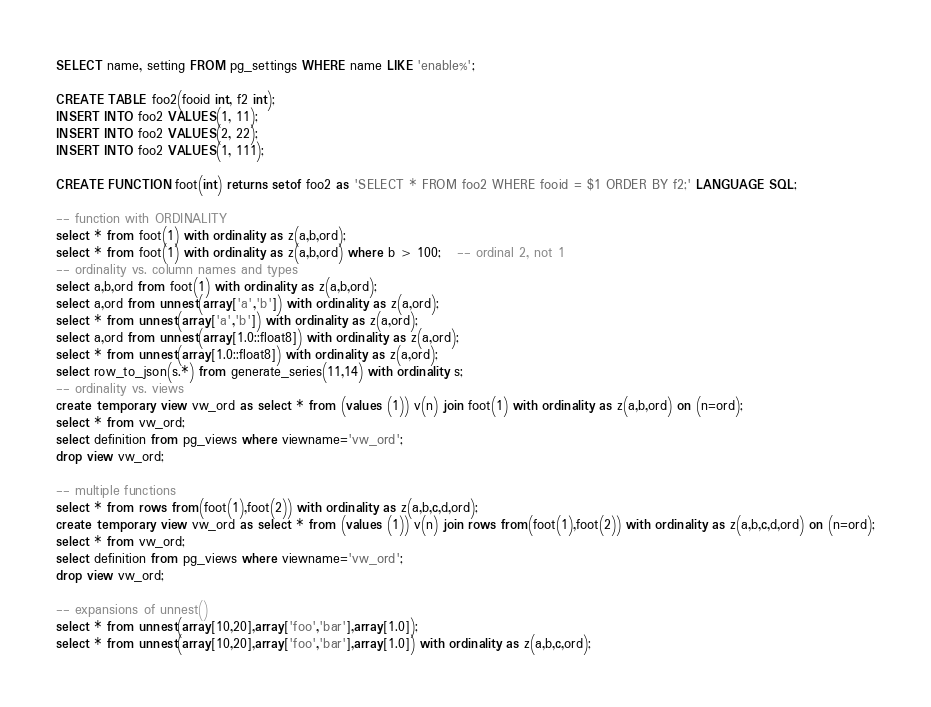Convert code to text. <code><loc_0><loc_0><loc_500><loc_500><_SQL_>SELECT name, setting FROM pg_settings WHERE name LIKE 'enable%';

CREATE TABLE foo2(fooid int, f2 int);
INSERT INTO foo2 VALUES(1, 11);
INSERT INTO foo2 VALUES(2, 22);
INSERT INTO foo2 VALUES(1, 111);

CREATE FUNCTION foot(int) returns setof foo2 as 'SELECT * FROM foo2 WHERE fooid = $1 ORDER BY f2;' LANGUAGE SQL;

-- function with ORDINALITY
select * from foot(1) with ordinality as z(a,b,ord);
select * from foot(1) with ordinality as z(a,b,ord) where b > 100;   -- ordinal 2, not 1
-- ordinality vs. column names and types
select a,b,ord from foot(1) with ordinality as z(a,b,ord);
select a,ord from unnest(array['a','b']) with ordinality as z(a,ord);
select * from unnest(array['a','b']) with ordinality as z(a,ord);
select a,ord from unnest(array[1.0::float8]) with ordinality as z(a,ord);
select * from unnest(array[1.0::float8]) with ordinality as z(a,ord);
select row_to_json(s.*) from generate_series(11,14) with ordinality s;
-- ordinality vs. views
create temporary view vw_ord as select * from (values (1)) v(n) join foot(1) with ordinality as z(a,b,ord) on (n=ord);
select * from vw_ord;
select definition from pg_views where viewname='vw_ord';
drop view vw_ord;

-- multiple functions
select * from rows from(foot(1),foot(2)) with ordinality as z(a,b,c,d,ord);
create temporary view vw_ord as select * from (values (1)) v(n) join rows from(foot(1),foot(2)) with ordinality as z(a,b,c,d,ord) on (n=ord);
select * from vw_ord;
select definition from pg_views where viewname='vw_ord';
drop view vw_ord;

-- expansions of unnest()
select * from unnest(array[10,20],array['foo','bar'],array[1.0]);
select * from unnest(array[10,20],array['foo','bar'],array[1.0]) with ordinality as z(a,b,c,ord);</code> 